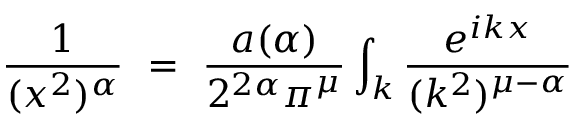Convert formula to latex. <formula><loc_0><loc_0><loc_500><loc_500>\frac { 1 } { ( x ^ { 2 } ) ^ { \alpha } } = \frac { a ( \alpha ) } { 2 ^ { 2 \alpha } \pi ^ { \mu } } \int _ { k } \frac { e ^ { i k x } } { ( k ^ { 2 } ) ^ { \mu - \alpha } }</formula> 